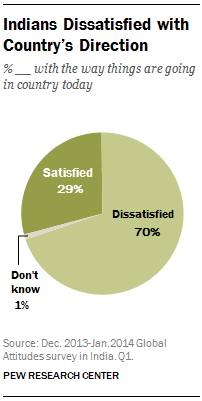Give some essential details in this illustration. According to a recent survey, the ratio between the percentage of Indians who are dissatisfied and the ones who are satisfied with the country's direction is 2.414... In India, approximately 0.7% of the population is dissatisfied with the direction of the country. 